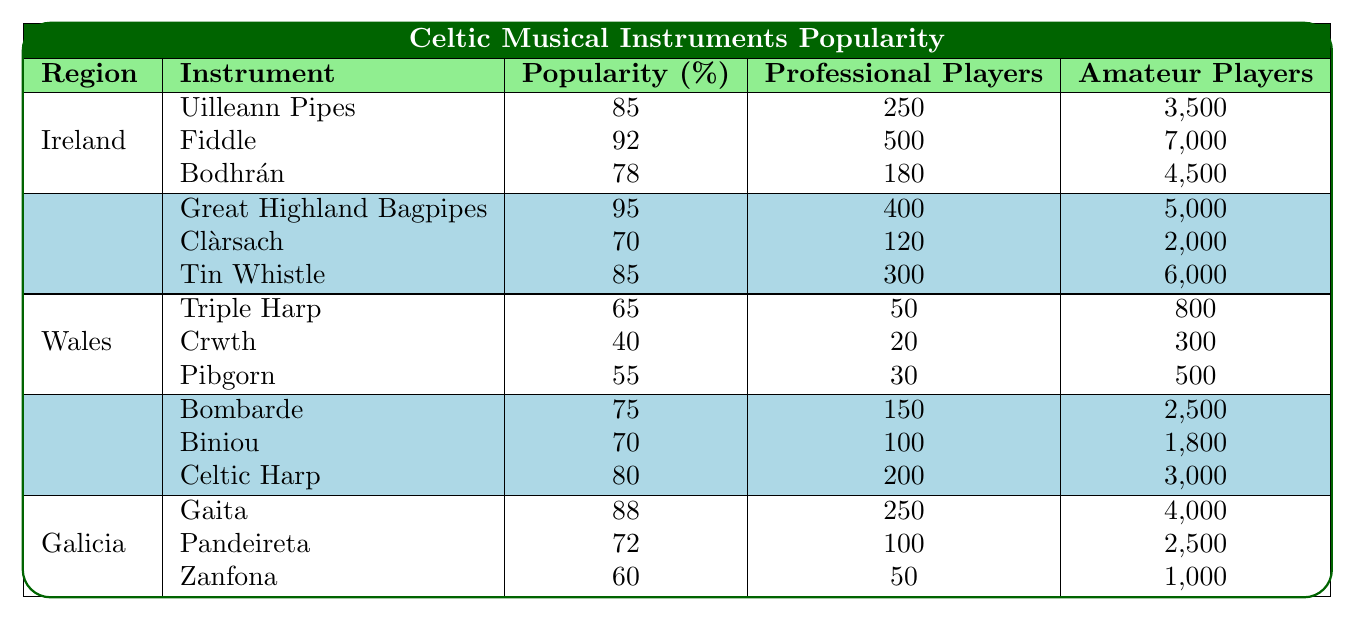What is the most popular instrument in Ireland? The table shows that the fiddle has a popularity rating of 92%, which is the highest among the instruments listed for Ireland.
Answer: Fiddle How many amateur players play the Great Highland Bagpipes in Scotland? Referring to the table, the Great Highland Bagpipes has 5,000 amateur players.
Answer: 5000 Which region has the least popular instrument listed? The Crwth in Wales has a popularity of 40%, which is less than any other listed instruments in the table.
Answer: Wales (Crwth) What is the total number of amateur players for Celtic Harp and Bombarde combined in Brittany? The table indicates that there are 3,000 amateur players for the Celtic Harp and 2,500 for the Bombarde. Adding these gives 3,000 + 2,500 = 5,500.
Answer: 5500 Is the number of professional players for the Uilleann Pipes greater than that of the Tin Whistle? The Uilleann Pipes have 250 professional players, while the Tin Whistle has 300. Thus, the Uilleann Pipes have fewer professional players than the Tin Whistle.
Answer: No What is the average popularity of instruments in Galicia? The popularity ratings for Galicia are 88 (Gaita), 72 (Pandeireta), and 60 (Zanfona). To find the average: (88 + 72 + 60) / 3 = 220 / 3 = 73.33, rounded gives 73.3.
Answer: 73.3 Which instrument has the highest number of professional players in Scotland? The Great Highland Bagpipes has 400 professional players, while other instruments in Scotland have fewer.
Answer: Great Highland Bagpipes What percentage difference in popularity exists between the Bodhrán and the Triple Harp? The Bodhrán's popularity is 78, and the Triple Harp's is 65. The difference is 78 - 65 = 13. To find the percentage difference relative to the Bodhrán: (13 / 78) * 100 = 16.67%.
Answer: 16.67% Which region has the highest total number of amateur players across all its instruments? Summing the amateur players by region: Ireland (3,500 + 7,000 + 4,500 = 15,000), Scotland (5,000 + 2,000 + 6,000 = 13,000), Wales (800 + 300 + 500 = 1,600), Brittany (2,500 + 1,800 + 3,000 = 7,300), Galicia (4,000 + 2,500 + 1,000 = 7,500). Ireland has the highest total of 15,000.
Answer: Ireland What is the total number of professional players in the regions of Brittany and Galicia combined? The total professional players in Brittany is 150 (Bombarde) + 100 (Biniou) + 200 (Celtic Harp) = 450. In Galicia, it is 250 (Gaita) + 100 (Pandeireta) + 50 (Zanfona) = 400. Thus, 450 + 400 = 850 combined.
Answer: 850 